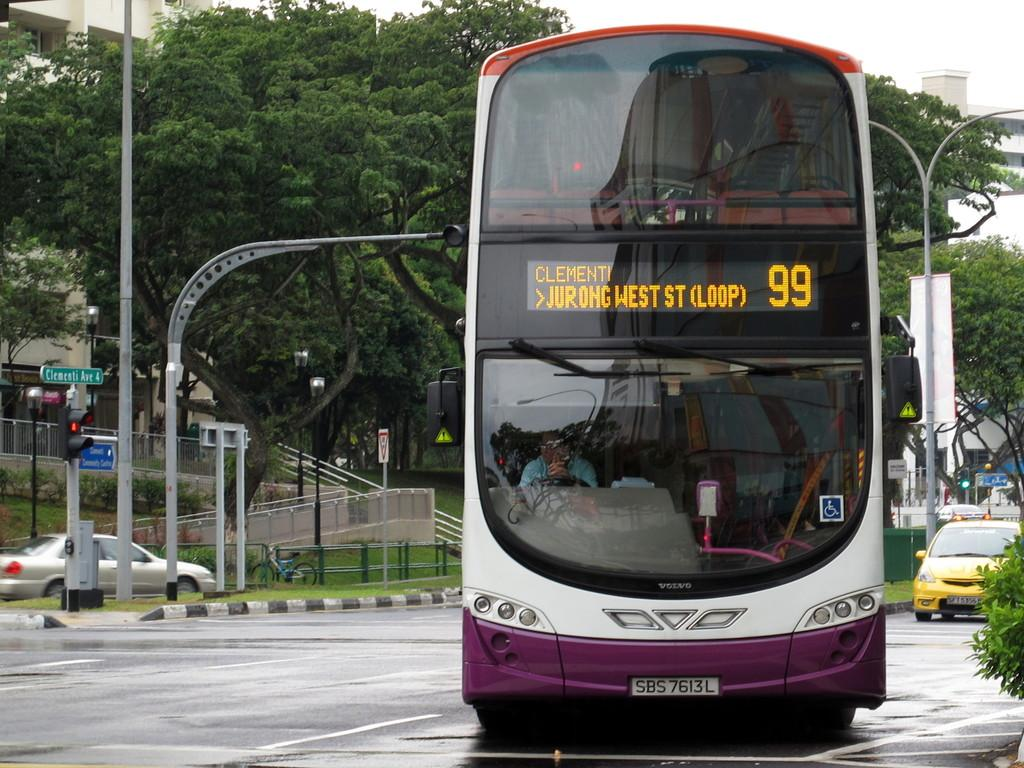What type of vehicle is on the road in the image? There is a double-decker bus on the road in the image. Are there any other vehicles visible in the image? Yes, there are cars behind the bus. What can be seen along the road in the image? Electric poles are visible in the image. What is visible in the background of the image? There are trees and buildings in the background. How many masks can be seen hanging on the trees in the image? There are no masks visible in the image; only trees, buildings, and electric poles can be seen. 